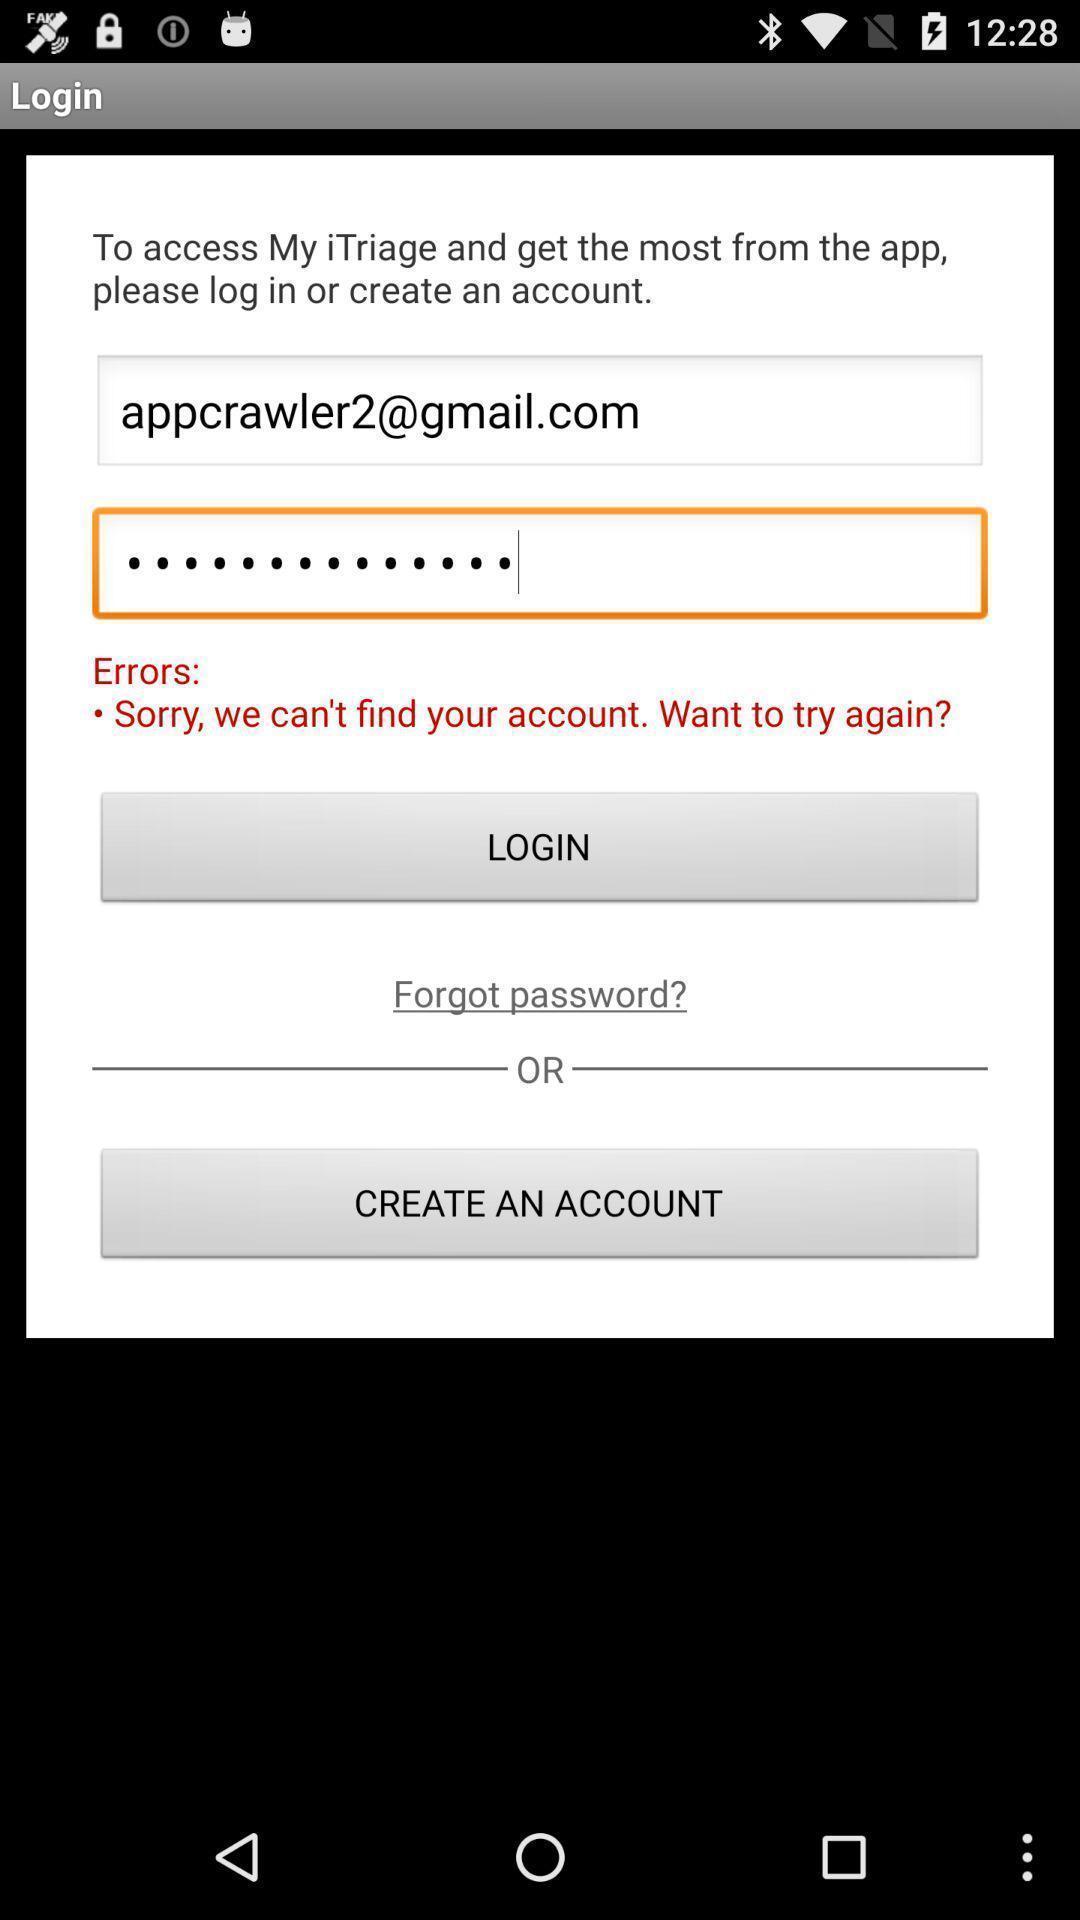Summarize the main components in this picture. Welcome to the login page. 